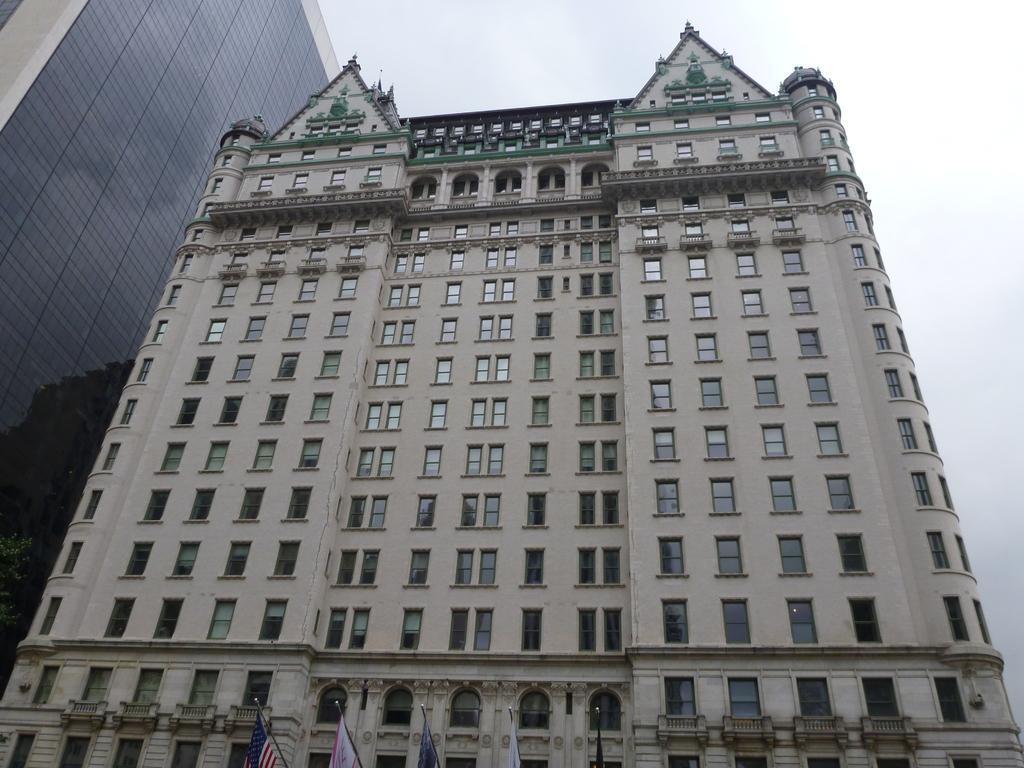Can you describe this image briefly? In this picture we can see buildings with windows, flags and in the background we can see the sky. 